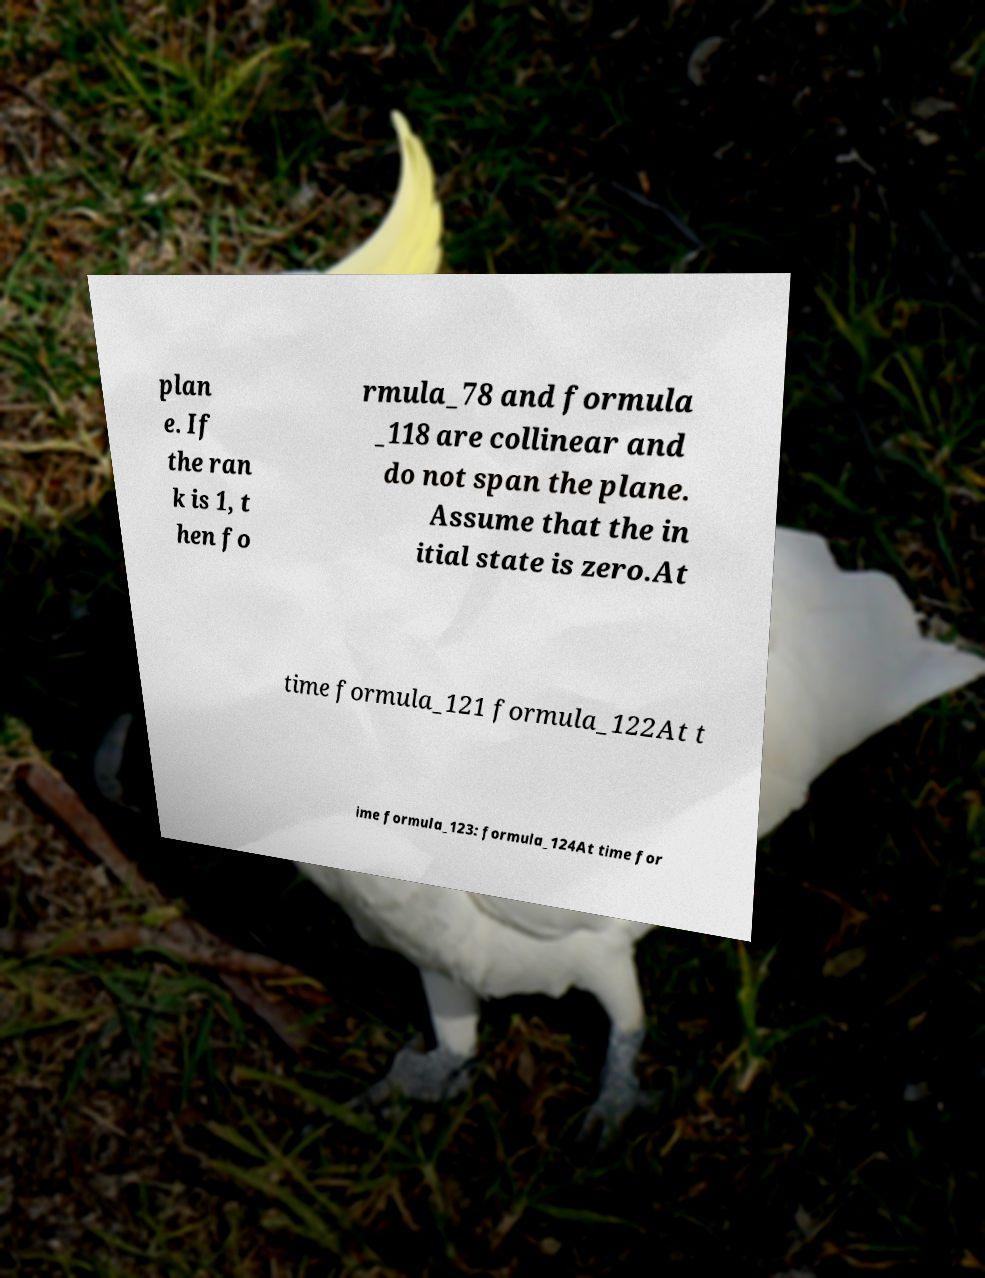Please read and relay the text visible in this image. What does it say? plan e. If the ran k is 1, t hen fo rmula_78 and formula _118 are collinear and do not span the plane. Assume that the in itial state is zero.At time formula_121 formula_122At t ime formula_123: formula_124At time for 